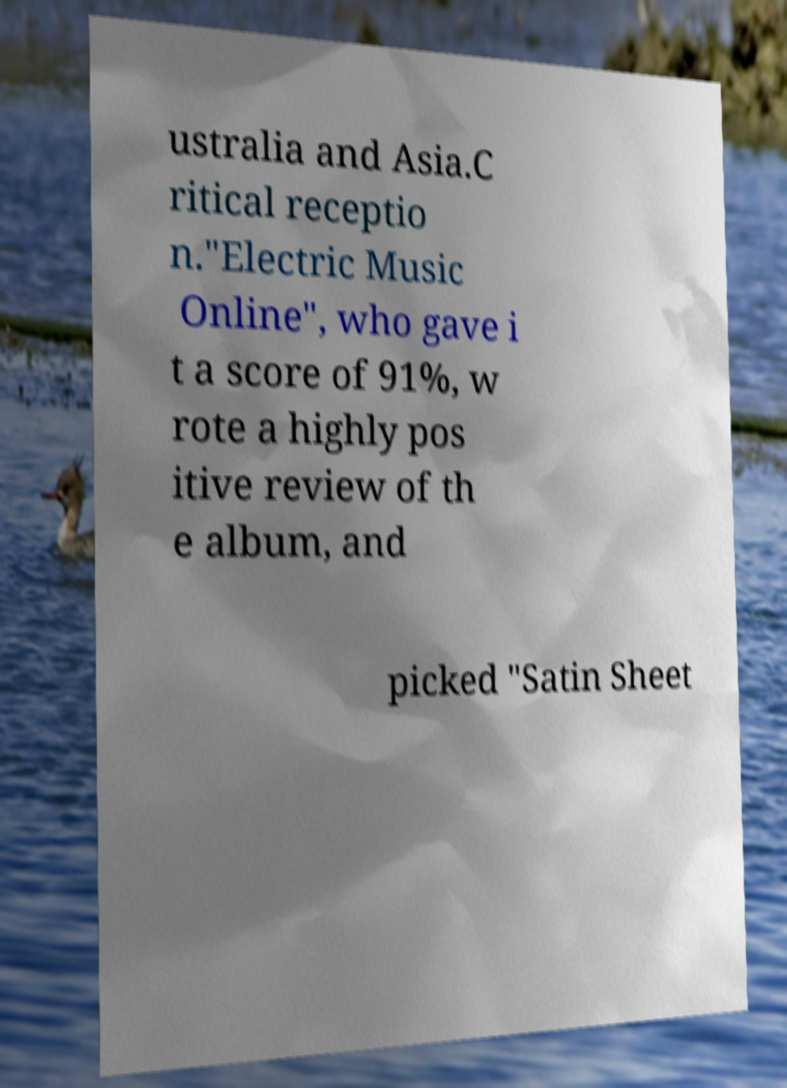Can you read and provide the text displayed in the image?This photo seems to have some interesting text. Can you extract and type it out for me? ustralia and Asia.C ritical receptio n."Electric Music Online", who gave i t a score of 91%, w rote a highly pos itive review of th e album, and picked "Satin Sheet 